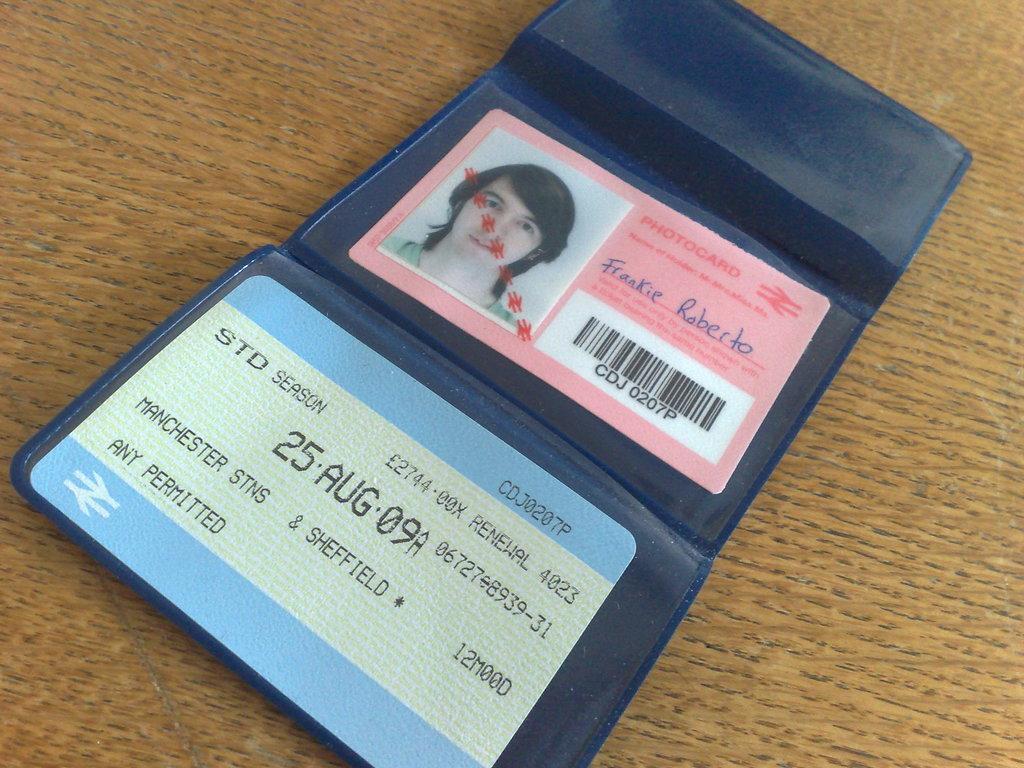Please provide a concise description of this image. In this image I can see a blue color purs, in the purs I can see two cards and a passport size photo and the purs is on the brown color surface. 